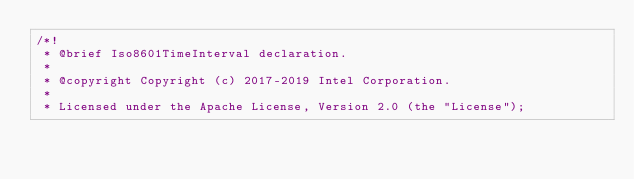<code> <loc_0><loc_0><loc_500><loc_500><_C++_>/*!
 * @brief Iso8601TimeInterval declaration.
 *
 * @copyright Copyright (c) 2017-2019 Intel Corporation.
 *
 * Licensed under the Apache License, Version 2.0 (the "License");</code> 